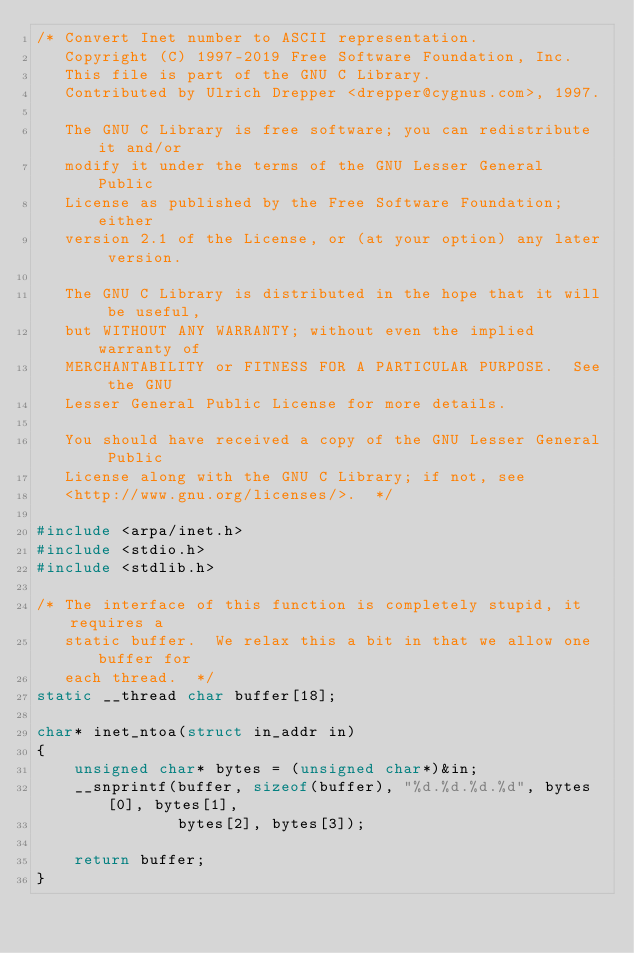Convert code to text. <code><loc_0><loc_0><loc_500><loc_500><_C_>/* Convert Inet number to ASCII representation.
   Copyright (C) 1997-2019 Free Software Foundation, Inc.
   This file is part of the GNU C Library.
   Contributed by Ulrich Drepper <drepper@cygnus.com>, 1997.

   The GNU C Library is free software; you can redistribute it and/or
   modify it under the terms of the GNU Lesser General Public
   License as published by the Free Software Foundation; either
   version 2.1 of the License, or (at your option) any later version.

   The GNU C Library is distributed in the hope that it will be useful,
   but WITHOUT ANY WARRANTY; without even the implied warranty of
   MERCHANTABILITY or FITNESS FOR A PARTICULAR PURPOSE.  See the GNU
   Lesser General Public License for more details.

   You should have received a copy of the GNU Lesser General Public
   License along with the GNU C Library; if not, see
   <http://www.gnu.org/licenses/>.  */

#include <arpa/inet.h>
#include <stdio.h>
#include <stdlib.h>

/* The interface of this function is completely stupid, it requires a
   static buffer.  We relax this a bit in that we allow one buffer for
   each thread.  */
static __thread char buffer[18];

char* inet_ntoa(struct in_addr in)
{
    unsigned char* bytes = (unsigned char*)&in;
    __snprintf(buffer, sizeof(buffer), "%d.%d.%d.%d", bytes[0], bytes[1],
               bytes[2], bytes[3]);

    return buffer;
}
</code> 